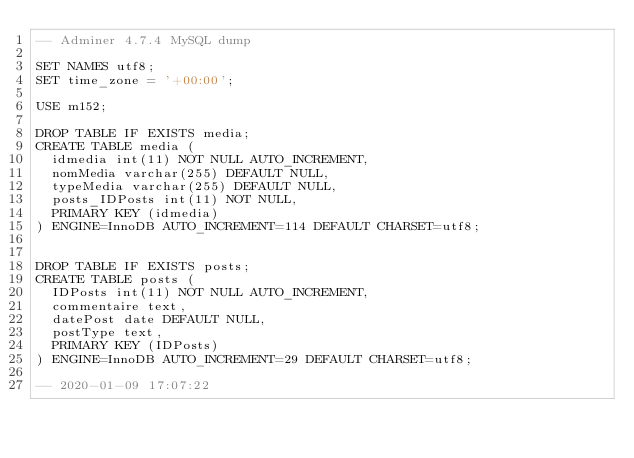<code> <loc_0><loc_0><loc_500><loc_500><_SQL_>-- Adminer 4.7.4 MySQL dump

SET NAMES utf8;
SET time_zone = '+00:00';

USE m152;

DROP TABLE IF EXISTS media;
CREATE TABLE media (
  idmedia int(11) NOT NULL AUTO_INCREMENT,
  nomMedia varchar(255) DEFAULT NULL,
  typeMedia varchar(255) DEFAULT NULL,
  posts_IDPosts int(11) NOT NULL,
  PRIMARY KEY (idmedia)
) ENGINE=InnoDB AUTO_INCREMENT=114 DEFAULT CHARSET=utf8;


DROP TABLE IF EXISTS posts;
CREATE TABLE posts (
  IDPosts int(11) NOT NULL AUTO_INCREMENT,
  commentaire text,
  datePost date DEFAULT NULL,
  postType text,
  PRIMARY KEY (IDPosts)
) ENGINE=InnoDB AUTO_INCREMENT=29 DEFAULT CHARSET=utf8;

-- 2020-01-09 17:07:22
</code> 